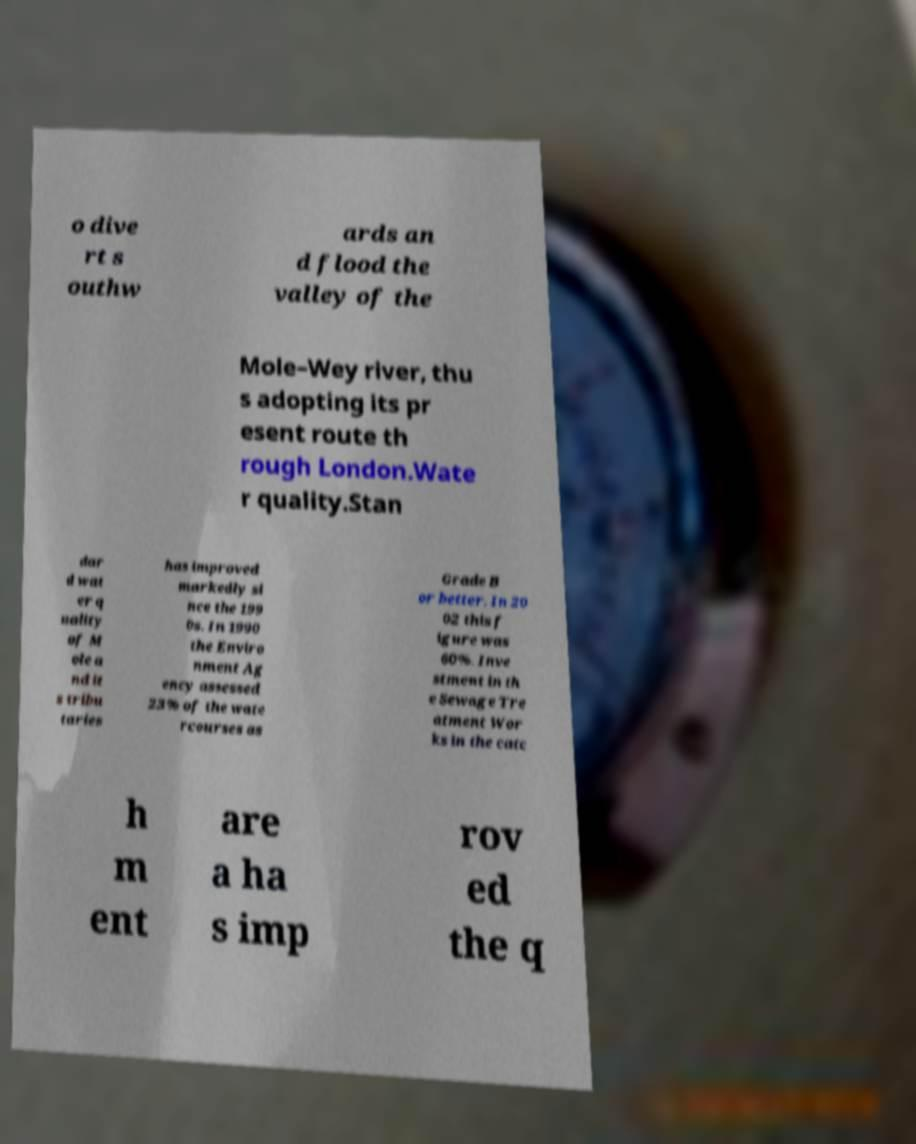Please identify and transcribe the text found in this image. o dive rt s outhw ards an d flood the valley of the Mole–Wey river, thu s adopting its pr esent route th rough London.Wate r quality.Stan dar d wat er q uality of M ole a nd it s tribu taries has improved markedly si nce the 199 0s. In 1990 the Enviro nment Ag ency assessed 23% of the wate rcourses as Grade B or better. In 20 02 this f igure was 60%. Inve stment in th e Sewage Tre atment Wor ks in the catc h m ent are a ha s imp rov ed the q 